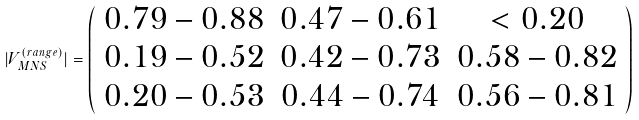<formula> <loc_0><loc_0><loc_500><loc_500>| V _ { M N S } ^ { ( r a n g e ) } | = \left ( \begin{array} { c c c } 0 . 7 9 - 0 . 8 8 & 0 . 4 7 - 0 . 6 1 & < 0 . 2 0 \\ 0 . 1 9 - 0 . 5 2 & 0 . 4 2 - 0 . 7 3 & 0 . 5 8 - 0 . 8 2 \\ 0 . 2 0 - 0 . 5 3 & 0 . 4 4 - 0 . 7 4 & 0 . 5 6 - 0 . 8 1 \end{array} \right )</formula> 